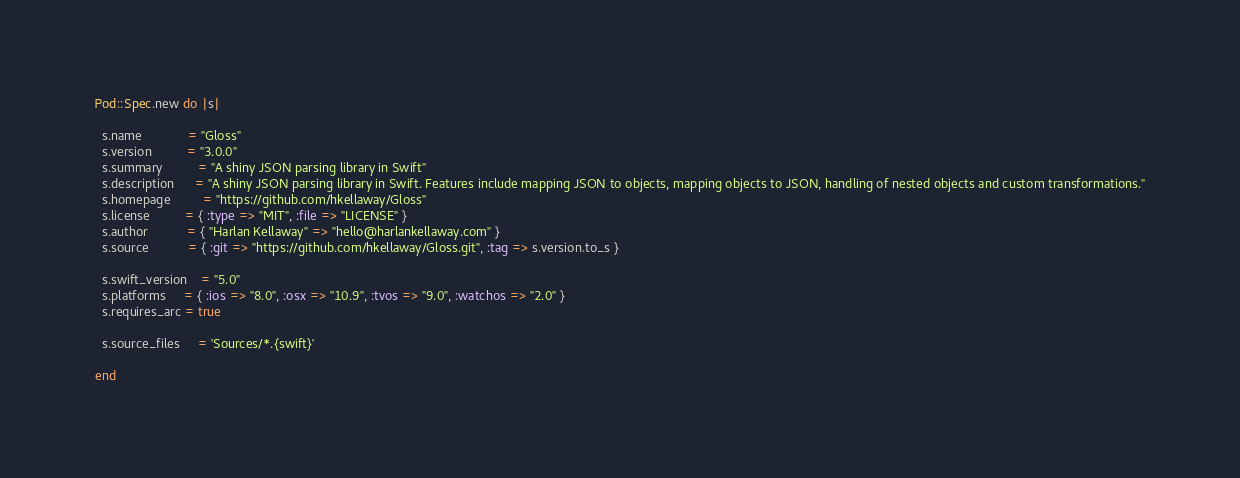<code> <loc_0><loc_0><loc_500><loc_500><_Ruby_>Pod::Spec.new do |s|

  s.name             = "Gloss"
  s.version          = "3.0.0"
  s.summary          = "A shiny JSON parsing library in Swift"
  s.description      = "A shiny JSON parsing library in Swift. Features include mapping JSON to objects, mapping objects to JSON, handling of nested objects and custom transformations."
  s.homepage         = "https://github.com/hkellaway/Gloss"
  s.license          = { :type => "MIT", :file => "LICENSE" }
  s.author           = { "Harlan Kellaway" => "hello@harlankellaway.com" }
  s.source           = { :git => "https://github.com/hkellaway/Gloss.git", :tag => s.version.to_s }
  
  s.swift_version    = "5.0"
  s.platforms     = { :ios => "8.0", :osx => "10.9", :tvos => "9.0", :watchos => "2.0" }
  s.requires_arc = true

  s.source_files     = 'Sources/*.{swift}'

end
</code> 